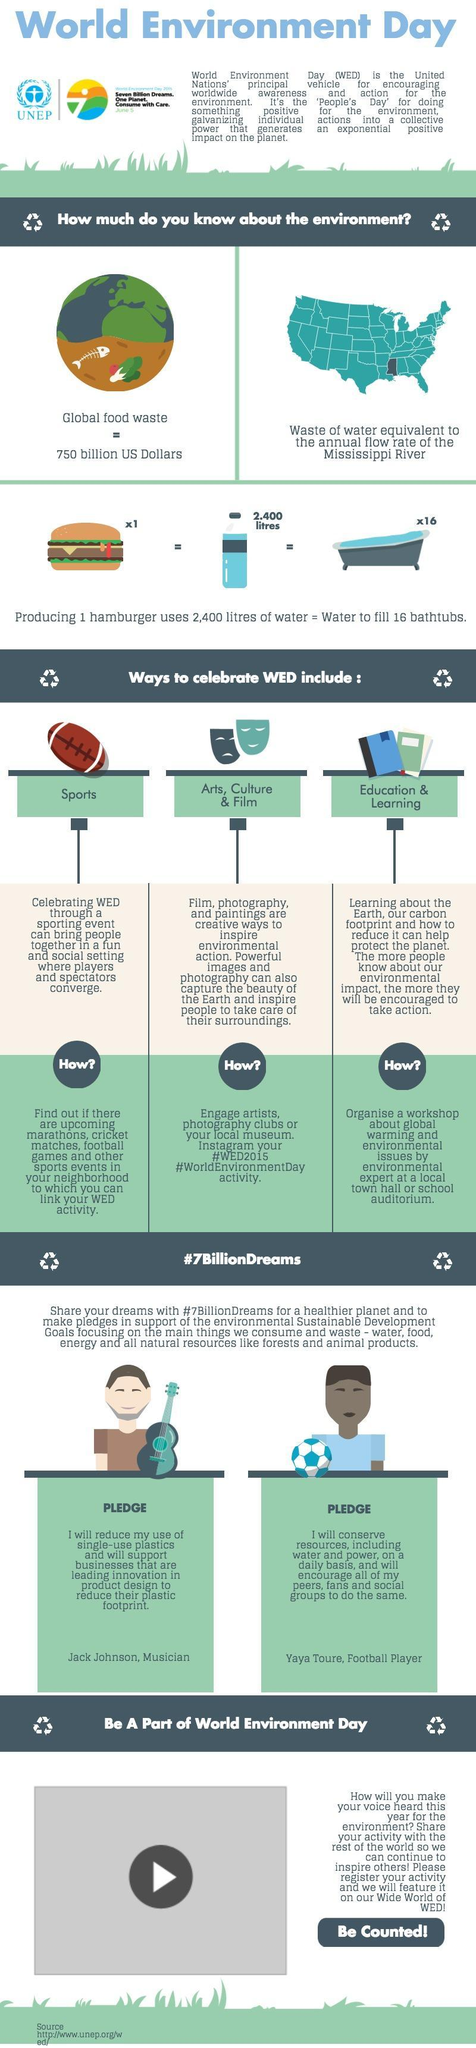What is the water wastage equal to
Answer the question with a short phrase. annual flow rate of the Mississippi River What is the value of the global food waste 750 billion US dollars what is the profession of the people who have shared their pledge in #7BillionDreams Musician, Football Player Water quantity required to filled 16 bath tubs is the same quantity to make what? 1 hamburger Through which mediums can WED be celebrated Sports, Art, Culture & Film, Education & Learning What are the # that can be used in Instagram # WED2015, #WorldEnvironment Day When is WED June 5 